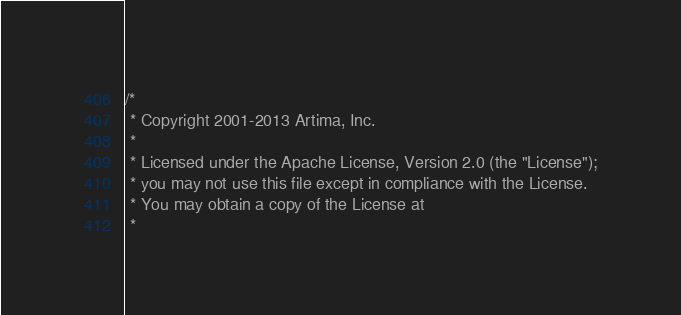Convert code to text. <code><loc_0><loc_0><loc_500><loc_500><_Scala_>/*
 * Copyright 2001-2013 Artima, Inc.
 *
 * Licensed under the Apache License, Version 2.0 (the "License");
 * you may not use this file except in compliance with the License.
 * You may obtain a copy of the License at
 *</code> 